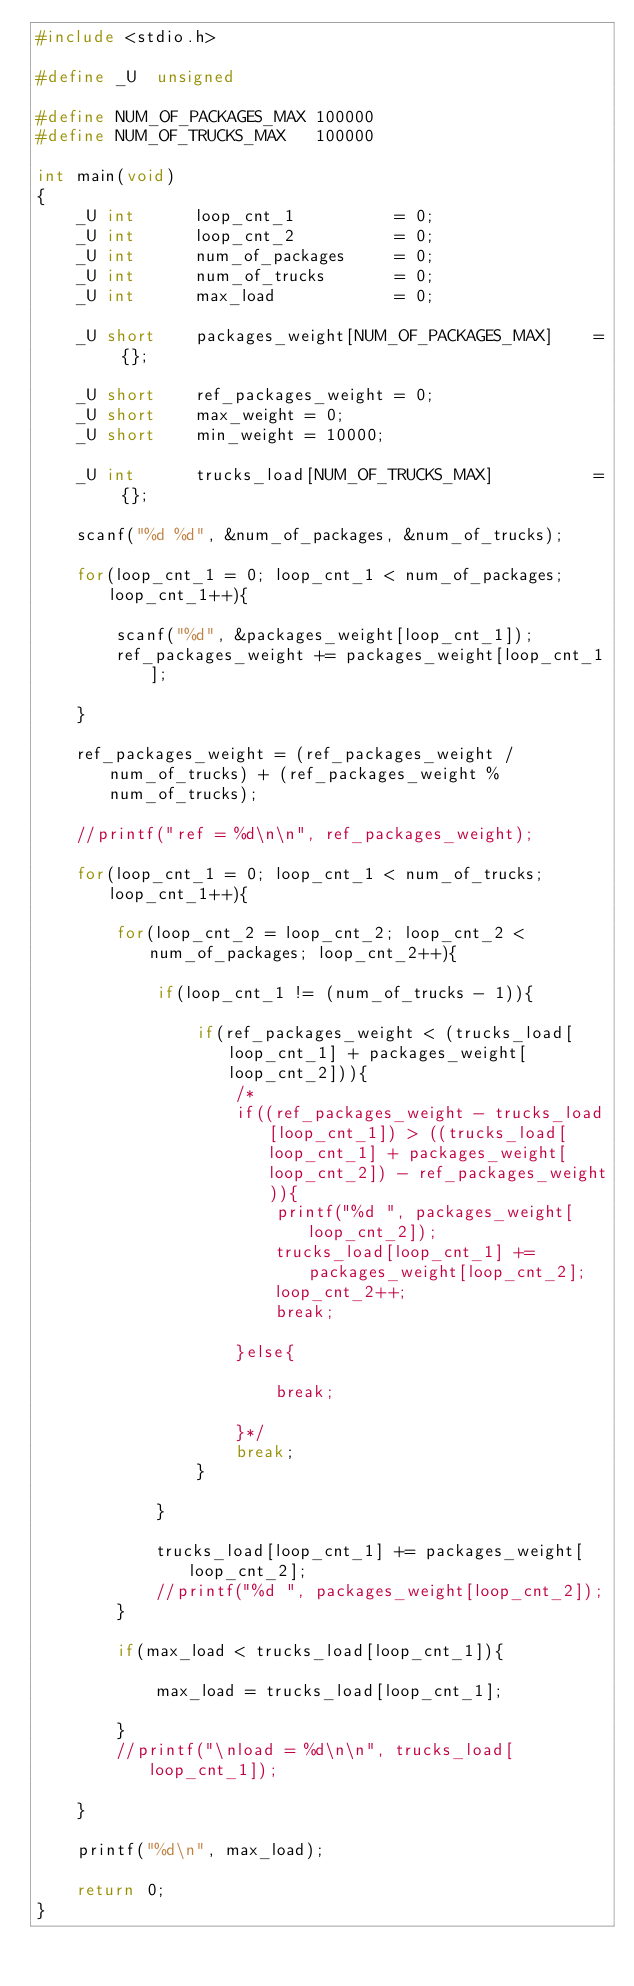Convert code to text. <code><loc_0><loc_0><loc_500><loc_500><_C_>#include <stdio.h>
 
#define _U  unsigned
 
#define NUM_OF_PACKAGES_MAX 100000
#define NUM_OF_TRUCKS_MAX   100000
 
int main(void)
{    
    _U int      loop_cnt_1          = 0;
    _U int      loop_cnt_2          = 0;
    _U int      num_of_packages     = 0;
    _U int      num_of_trucks       = 0;
    _U int      max_load            = 0;
     
    _U short    packages_weight[NUM_OF_PACKAGES_MAX]    = {};
     
    _U short    ref_packages_weight = 0;
    _U short    max_weight = 0;
    _U short    min_weight = 10000;
     
    _U int      trucks_load[NUM_OF_TRUCKS_MAX]          = {};
 
    scanf("%d %d", &num_of_packages, &num_of_trucks);
     
    for(loop_cnt_1 = 0; loop_cnt_1 < num_of_packages; loop_cnt_1++){
         
        scanf("%d", &packages_weight[loop_cnt_1]);
        ref_packages_weight += packages_weight[loop_cnt_1];
        
    }
     
    ref_packages_weight = (ref_packages_weight / num_of_trucks) + (ref_packages_weight % num_of_trucks);
    
    //printf("ref = %d\n\n", ref_packages_weight);
     
    for(loop_cnt_1 = 0; loop_cnt_1 < num_of_trucks; loop_cnt_1++){
         
        for(loop_cnt_2 = loop_cnt_2; loop_cnt_2 < num_of_packages; loop_cnt_2++){
             
            if(loop_cnt_1 != (num_of_trucks - 1)){
             
                if(ref_packages_weight < (trucks_load[loop_cnt_1] + packages_weight[loop_cnt_2])){
                    /* 
                    if((ref_packages_weight - trucks_load[loop_cnt_1]) > ((trucks_load[loop_cnt_1] + packages_weight[loop_cnt_2]) - ref_packages_weight)){
                        printf("%d ", packages_weight[loop_cnt_2]); 
                        trucks_load[loop_cnt_1] += packages_weight[loop_cnt_2];
                        loop_cnt_2++;
                        break;
                         
                    }else{
                         
                        break;
                         
                    }*/
                    break;
                }
                 
            }
                 
            trucks_load[loop_cnt_1] += packages_weight[loop_cnt_2];
            //printf("%d ", packages_weight[loop_cnt_2]); 
        }
         
        if(max_load < trucks_load[loop_cnt_1]){
             
            max_load = trucks_load[loop_cnt_1];
             
        }
        //printf("\nload = %d\n\n", trucks_load[loop_cnt_1]);
         
    }
     
    printf("%d\n", max_load);
     
    return 0;
}
</code> 